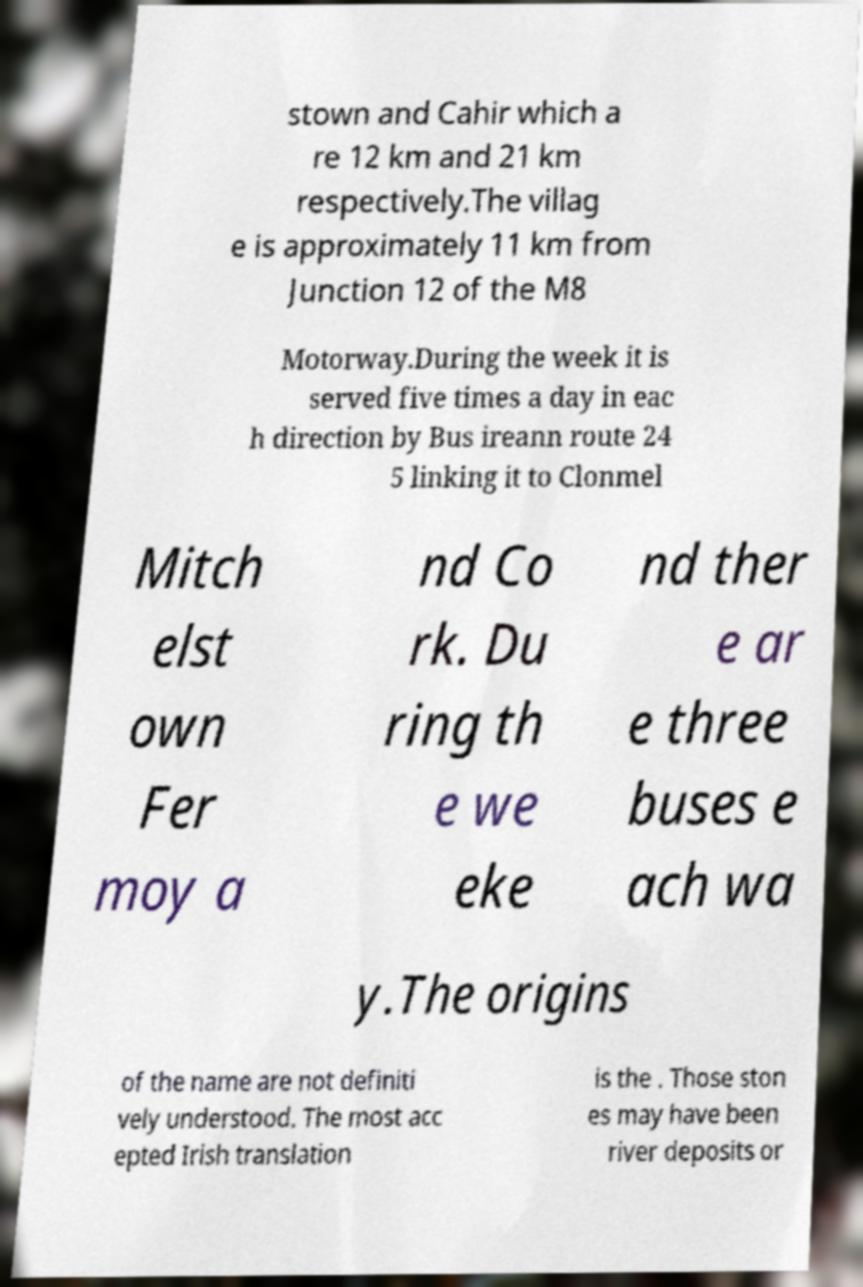Please identify and transcribe the text found in this image. stown and Cahir which a re 12 km and 21 km respectively.The villag e is approximately 11 km from Junction 12 of the M8 Motorway.During the week it is served five times a day in eac h direction by Bus ireann route 24 5 linking it to Clonmel Mitch elst own Fer moy a nd Co rk. Du ring th e we eke nd ther e ar e three buses e ach wa y.The origins of the name are not definiti vely understood. The most acc epted Irish translation is the . Those ston es may have been river deposits or 